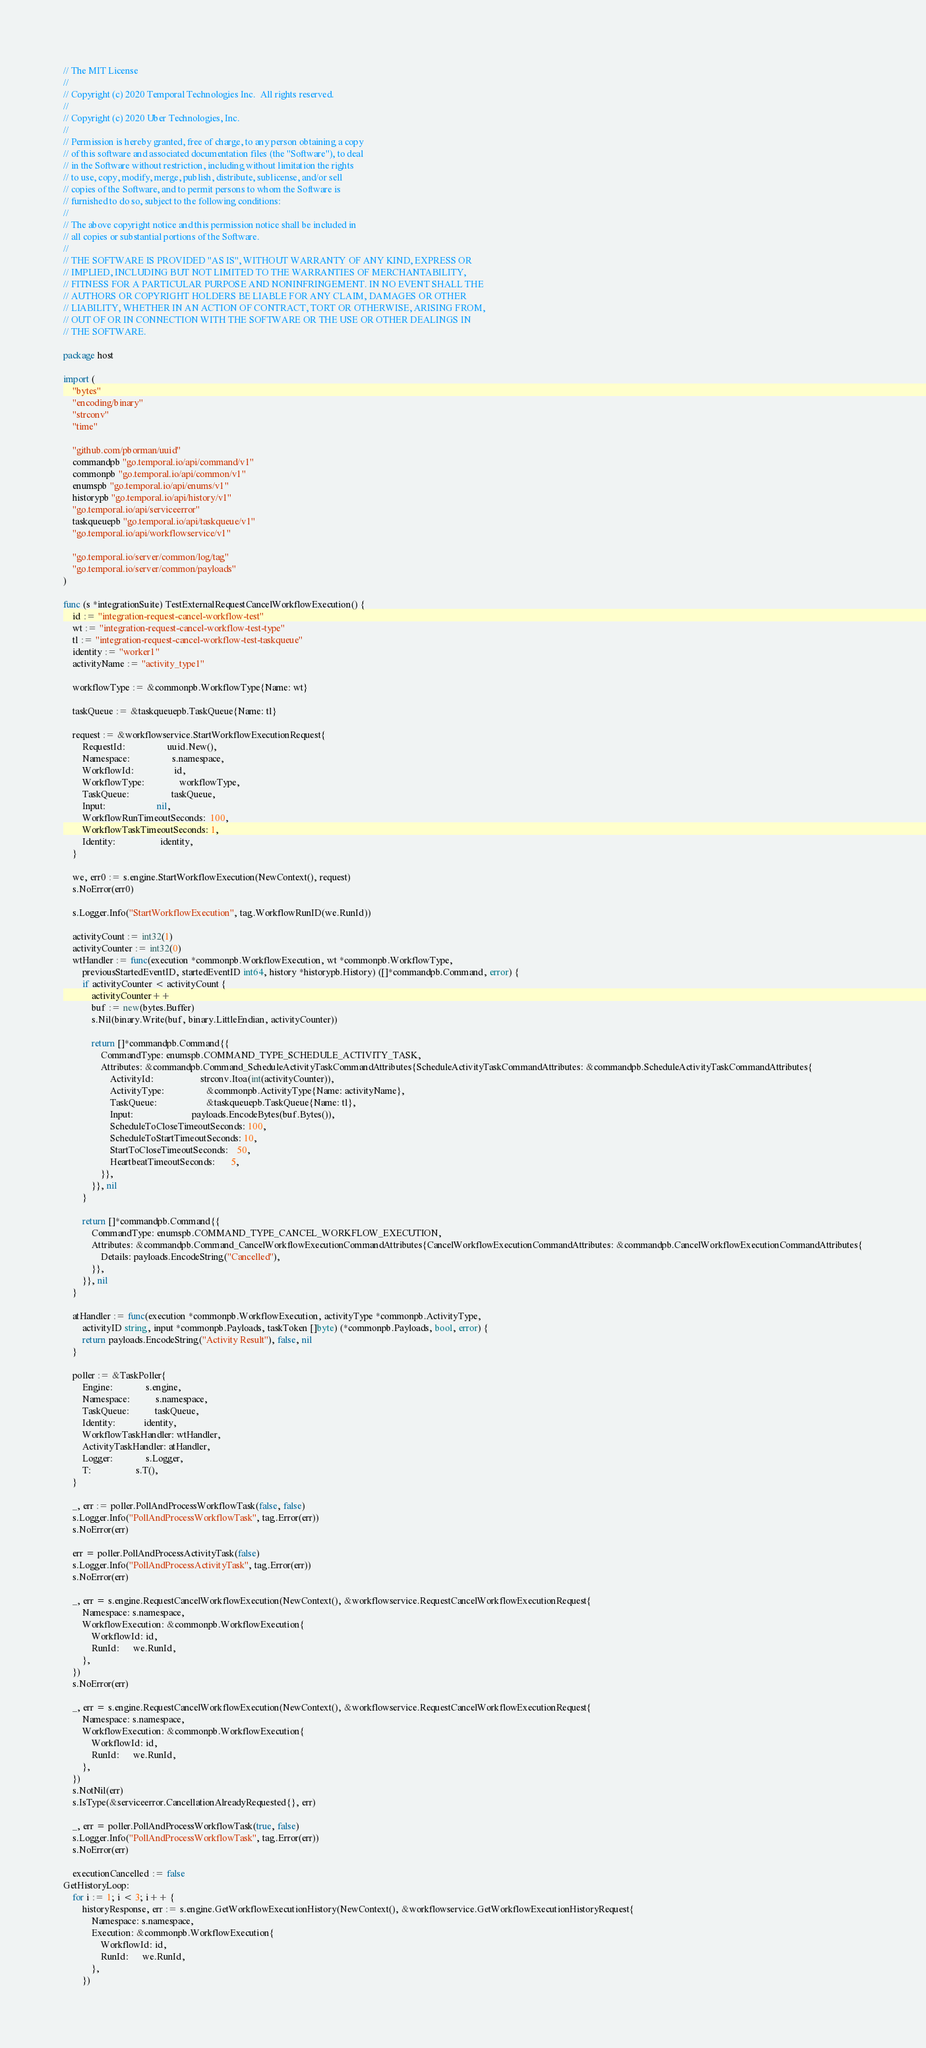Convert code to text. <code><loc_0><loc_0><loc_500><loc_500><_Go_>// The MIT License
//
// Copyright (c) 2020 Temporal Technologies Inc.  All rights reserved.
//
// Copyright (c) 2020 Uber Technologies, Inc.
//
// Permission is hereby granted, free of charge, to any person obtaining a copy
// of this software and associated documentation files (the "Software"), to deal
// in the Software without restriction, including without limitation the rights
// to use, copy, modify, merge, publish, distribute, sublicense, and/or sell
// copies of the Software, and to permit persons to whom the Software is
// furnished to do so, subject to the following conditions:
//
// The above copyright notice and this permission notice shall be included in
// all copies or substantial portions of the Software.
//
// THE SOFTWARE IS PROVIDED "AS IS", WITHOUT WARRANTY OF ANY KIND, EXPRESS OR
// IMPLIED, INCLUDING BUT NOT LIMITED TO THE WARRANTIES OF MERCHANTABILITY,
// FITNESS FOR A PARTICULAR PURPOSE AND NONINFRINGEMENT. IN NO EVENT SHALL THE
// AUTHORS OR COPYRIGHT HOLDERS BE LIABLE FOR ANY CLAIM, DAMAGES OR OTHER
// LIABILITY, WHETHER IN AN ACTION OF CONTRACT, TORT OR OTHERWISE, ARISING FROM,
// OUT OF OR IN CONNECTION WITH THE SOFTWARE OR THE USE OR OTHER DEALINGS IN
// THE SOFTWARE.

package host

import (
	"bytes"
	"encoding/binary"
	"strconv"
	"time"

	"github.com/pborman/uuid"
	commandpb "go.temporal.io/api/command/v1"
	commonpb "go.temporal.io/api/common/v1"
	enumspb "go.temporal.io/api/enums/v1"
	historypb "go.temporal.io/api/history/v1"
	"go.temporal.io/api/serviceerror"
	taskqueuepb "go.temporal.io/api/taskqueue/v1"
	"go.temporal.io/api/workflowservice/v1"

	"go.temporal.io/server/common/log/tag"
	"go.temporal.io/server/common/payloads"
)

func (s *integrationSuite) TestExternalRequestCancelWorkflowExecution() {
	id := "integration-request-cancel-workflow-test"
	wt := "integration-request-cancel-workflow-test-type"
	tl := "integration-request-cancel-workflow-test-taskqueue"
	identity := "worker1"
	activityName := "activity_type1"

	workflowType := &commonpb.WorkflowType{Name: wt}

	taskQueue := &taskqueuepb.TaskQueue{Name: tl}

	request := &workflowservice.StartWorkflowExecutionRequest{
		RequestId:                  uuid.New(),
		Namespace:                  s.namespace,
		WorkflowId:                 id,
		WorkflowType:               workflowType,
		TaskQueue:                  taskQueue,
		Input:                      nil,
		WorkflowRunTimeoutSeconds:  100,
		WorkflowTaskTimeoutSeconds: 1,
		Identity:                   identity,
	}

	we, err0 := s.engine.StartWorkflowExecution(NewContext(), request)
	s.NoError(err0)

	s.Logger.Info("StartWorkflowExecution", tag.WorkflowRunID(we.RunId))

	activityCount := int32(1)
	activityCounter := int32(0)
	wtHandler := func(execution *commonpb.WorkflowExecution, wt *commonpb.WorkflowType,
		previousStartedEventID, startedEventID int64, history *historypb.History) ([]*commandpb.Command, error) {
		if activityCounter < activityCount {
			activityCounter++
			buf := new(bytes.Buffer)
			s.Nil(binary.Write(buf, binary.LittleEndian, activityCounter))

			return []*commandpb.Command{{
				CommandType: enumspb.COMMAND_TYPE_SCHEDULE_ACTIVITY_TASK,
				Attributes: &commandpb.Command_ScheduleActivityTaskCommandAttributes{ScheduleActivityTaskCommandAttributes: &commandpb.ScheduleActivityTaskCommandAttributes{
					ActivityId:                    strconv.Itoa(int(activityCounter)),
					ActivityType:                  &commonpb.ActivityType{Name: activityName},
					TaskQueue:                     &taskqueuepb.TaskQueue{Name: tl},
					Input:                         payloads.EncodeBytes(buf.Bytes()),
					ScheduleToCloseTimeoutSeconds: 100,
					ScheduleToStartTimeoutSeconds: 10,
					StartToCloseTimeoutSeconds:    50,
					HeartbeatTimeoutSeconds:       5,
				}},
			}}, nil
		}

		return []*commandpb.Command{{
			CommandType: enumspb.COMMAND_TYPE_CANCEL_WORKFLOW_EXECUTION,
			Attributes: &commandpb.Command_CancelWorkflowExecutionCommandAttributes{CancelWorkflowExecutionCommandAttributes: &commandpb.CancelWorkflowExecutionCommandAttributes{
				Details: payloads.EncodeString("Cancelled"),
			}},
		}}, nil
	}

	atHandler := func(execution *commonpb.WorkflowExecution, activityType *commonpb.ActivityType,
		activityID string, input *commonpb.Payloads, taskToken []byte) (*commonpb.Payloads, bool, error) {
		return payloads.EncodeString("Activity Result"), false, nil
	}

	poller := &TaskPoller{
		Engine:              s.engine,
		Namespace:           s.namespace,
		TaskQueue:           taskQueue,
		Identity:            identity,
		WorkflowTaskHandler: wtHandler,
		ActivityTaskHandler: atHandler,
		Logger:              s.Logger,
		T:                   s.T(),
	}

	_, err := poller.PollAndProcessWorkflowTask(false, false)
	s.Logger.Info("PollAndProcessWorkflowTask", tag.Error(err))
	s.NoError(err)

	err = poller.PollAndProcessActivityTask(false)
	s.Logger.Info("PollAndProcessActivityTask", tag.Error(err))
	s.NoError(err)

	_, err = s.engine.RequestCancelWorkflowExecution(NewContext(), &workflowservice.RequestCancelWorkflowExecutionRequest{
		Namespace: s.namespace,
		WorkflowExecution: &commonpb.WorkflowExecution{
			WorkflowId: id,
			RunId:      we.RunId,
		},
	})
	s.NoError(err)

	_, err = s.engine.RequestCancelWorkflowExecution(NewContext(), &workflowservice.RequestCancelWorkflowExecutionRequest{
		Namespace: s.namespace,
		WorkflowExecution: &commonpb.WorkflowExecution{
			WorkflowId: id,
			RunId:      we.RunId,
		},
	})
	s.NotNil(err)
	s.IsType(&serviceerror.CancellationAlreadyRequested{}, err)

	_, err = poller.PollAndProcessWorkflowTask(true, false)
	s.Logger.Info("PollAndProcessWorkflowTask", tag.Error(err))
	s.NoError(err)

	executionCancelled := false
GetHistoryLoop:
	for i := 1; i < 3; i++ {
		historyResponse, err := s.engine.GetWorkflowExecutionHistory(NewContext(), &workflowservice.GetWorkflowExecutionHistoryRequest{
			Namespace: s.namespace,
			Execution: &commonpb.WorkflowExecution{
				WorkflowId: id,
				RunId:      we.RunId,
			},
		})</code> 